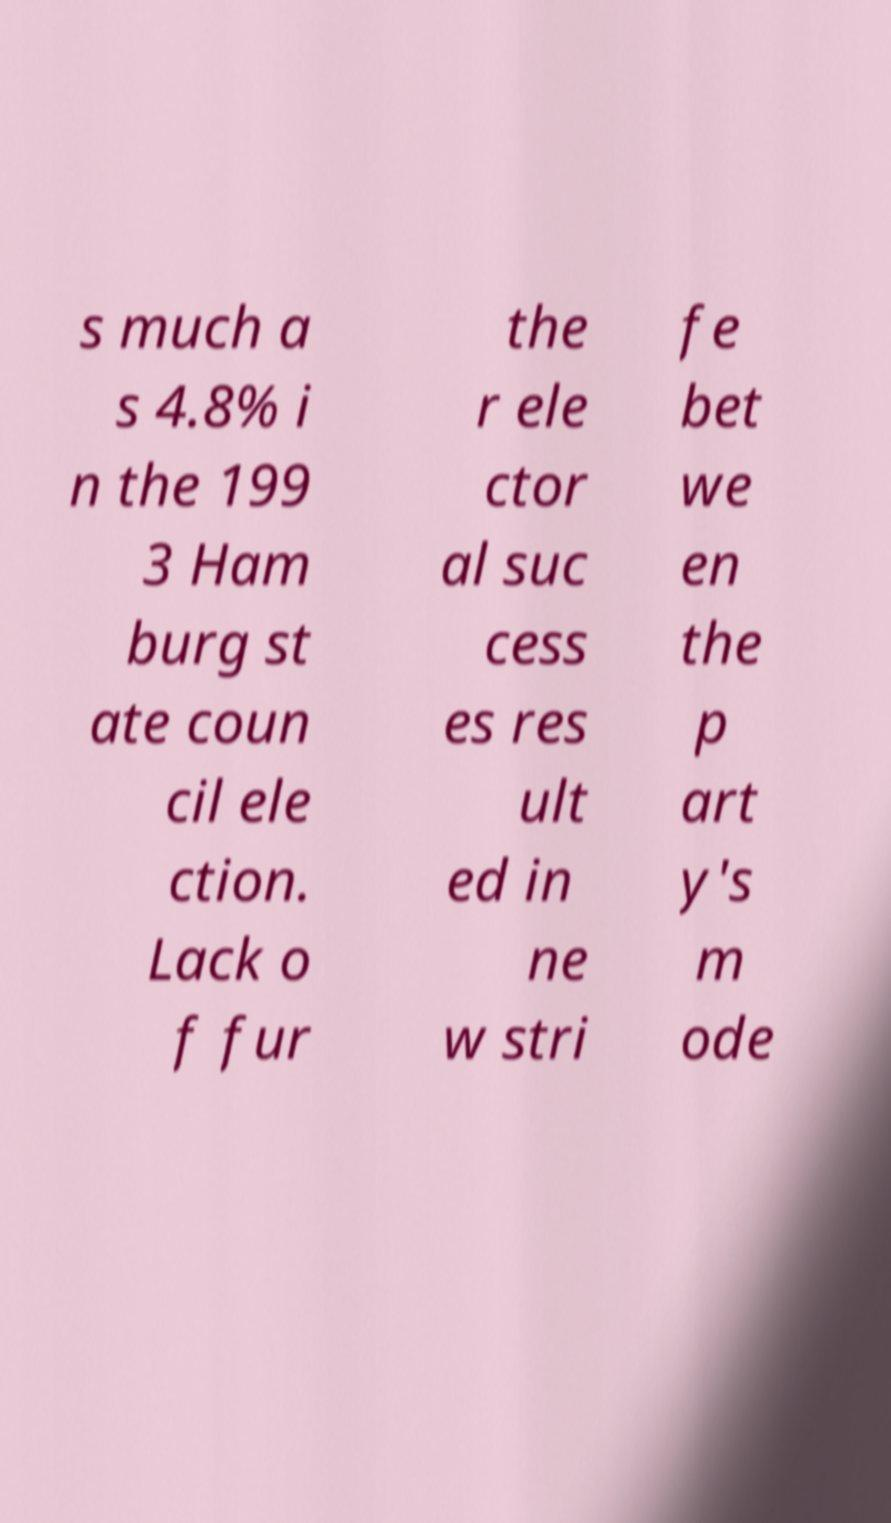What messages or text are displayed in this image? I need them in a readable, typed format. s much a s 4.8% i n the 199 3 Ham burg st ate coun cil ele ction. Lack o f fur the r ele ctor al suc cess es res ult ed in ne w stri fe bet we en the p art y's m ode 